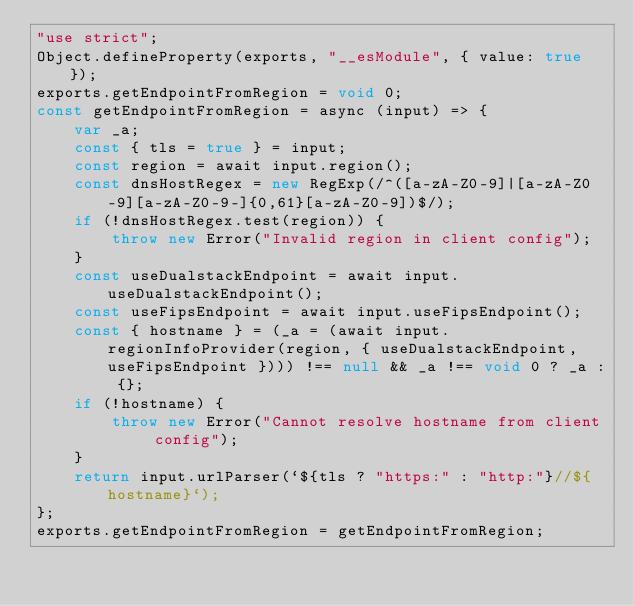Convert code to text. <code><loc_0><loc_0><loc_500><loc_500><_JavaScript_>"use strict";
Object.defineProperty(exports, "__esModule", { value: true });
exports.getEndpointFromRegion = void 0;
const getEndpointFromRegion = async (input) => {
    var _a;
    const { tls = true } = input;
    const region = await input.region();
    const dnsHostRegex = new RegExp(/^([a-zA-Z0-9]|[a-zA-Z0-9][a-zA-Z0-9-]{0,61}[a-zA-Z0-9])$/);
    if (!dnsHostRegex.test(region)) {
        throw new Error("Invalid region in client config");
    }
    const useDualstackEndpoint = await input.useDualstackEndpoint();
    const useFipsEndpoint = await input.useFipsEndpoint();
    const { hostname } = (_a = (await input.regionInfoProvider(region, { useDualstackEndpoint, useFipsEndpoint }))) !== null && _a !== void 0 ? _a : {};
    if (!hostname) {
        throw new Error("Cannot resolve hostname from client config");
    }
    return input.urlParser(`${tls ? "https:" : "http:"}//${hostname}`);
};
exports.getEndpointFromRegion = getEndpointFromRegion;
</code> 